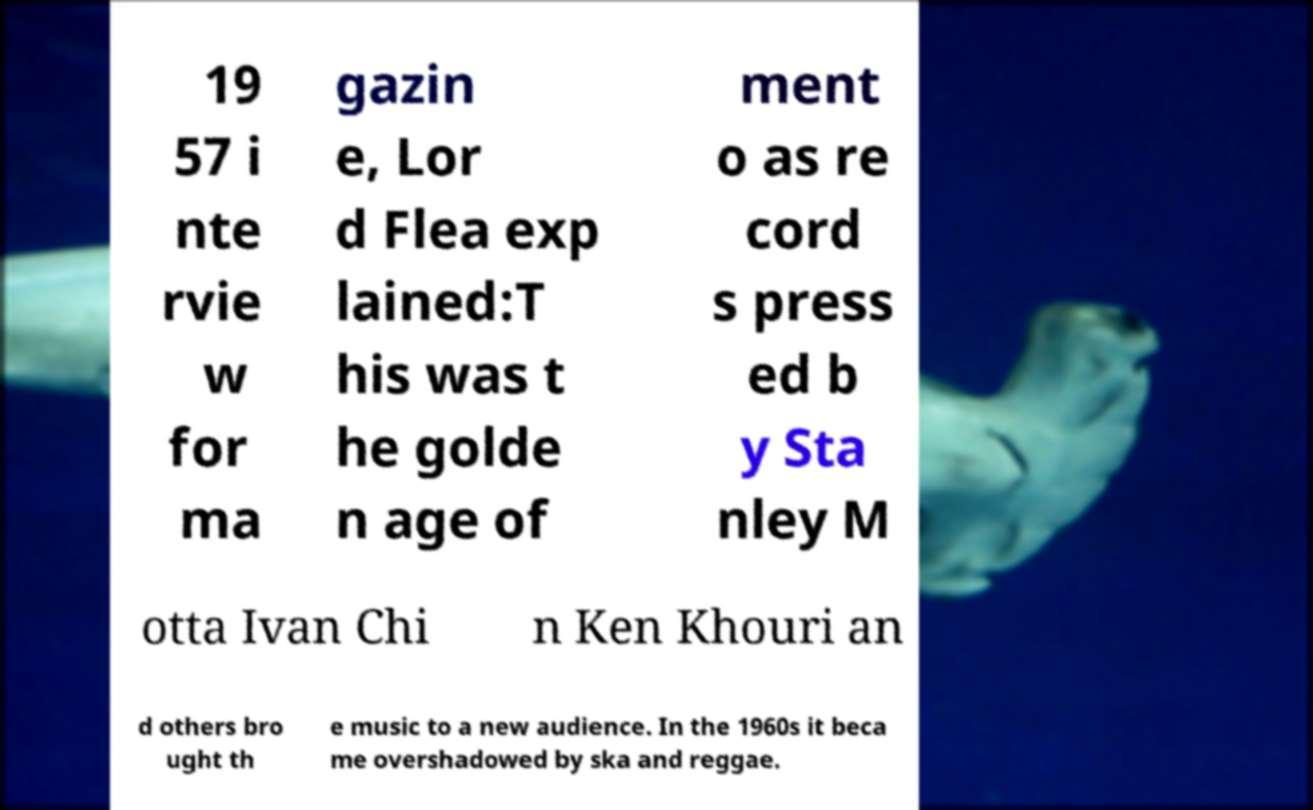Can you read and provide the text displayed in the image?This photo seems to have some interesting text. Can you extract and type it out for me? 19 57 i nte rvie w for ma gazin e, Lor d Flea exp lained:T his was t he golde n age of ment o as re cord s press ed b y Sta nley M otta Ivan Chi n Ken Khouri an d others bro ught th e music to a new audience. In the 1960s it beca me overshadowed by ska and reggae. 